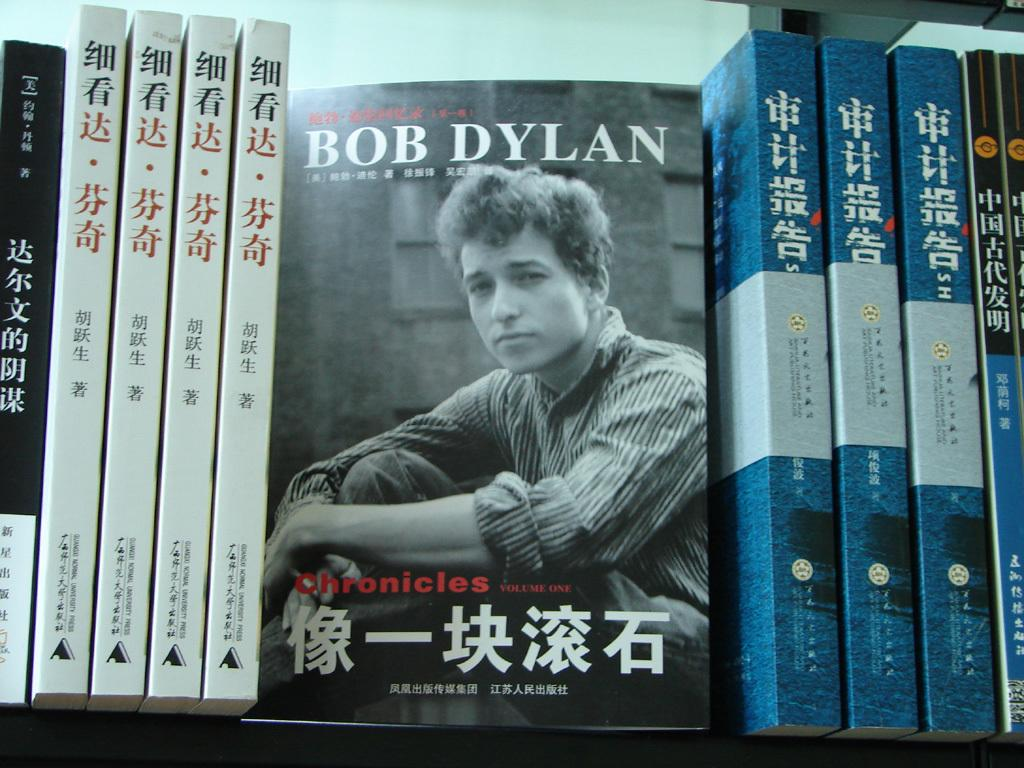Provide a one-sentence caption for the provided image. A bookshelf with a  Bob Dylan book in the middle. 